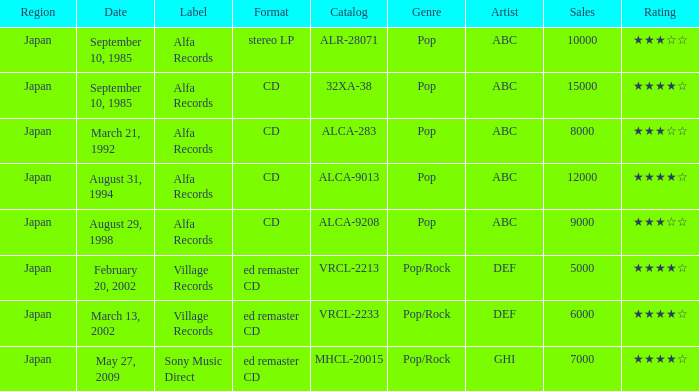Which Catalog was formated as a CD under the label Alfa Records? 32XA-38, ALCA-283, ALCA-9013, ALCA-9208. Give me the full table as a dictionary. {'header': ['Region', 'Date', 'Label', 'Format', 'Catalog', 'Genre', 'Artist', 'Sales', 'Rating'], 'rows': [['Japan', 'September 10, 1985', 'Alfa Records', 'stereo LP', 'ALR-28071', 'Pop', 'ABC', '10000', '★★★☆☆'], ['Japan', 'September 10, 1985', 'Alfa Records', 'CD', '32XA-38', 'Pop', 'ABC', '15000', '★★★★☆'], ['Japan', 'March 21, 1992', 'Alfa Records', 'CD', 'ALCA-283', 'Pop', 'ABC', '8000', '★★★☆☆'], ['Japan', 'August 31, 1994', 'Alfa Records', 'CD', 'ALCA-9013', 'Pop', 'ABC', '12000', '★★★★☆'], ['Japan', 'August 29, 1998', 'Alfa Records', 'CD', 'ALCA-9208', 'Pop', 'ABC', '9000', '★★★☆☆'], ['Japan', 'February 20, 2002', 'Village Records', 'ed remaster CD', 'VRCL-2213', 'Pop/Rock', 'DEF', '5000', '★★★★☆'], ['Japan', 'March 13, 2002', 'Village Records', 'ed remaster CD', 'VRCL-2233', 'Pop/Rock', 'DEF', '6000', '★★★★☆'], ['Japan', 'May 27, 2009', 'Sony Music Direct', 'ed remaster CD', 'MHCL-20015', 'Pop/Rock', 'GHI', '7000', '★★★★☆']]} 